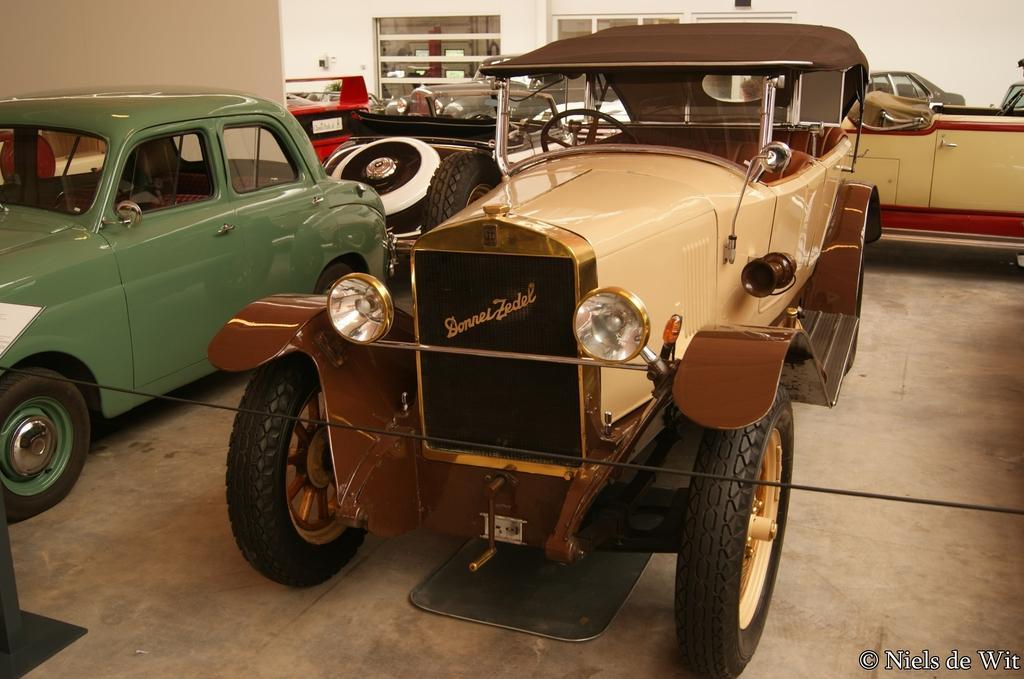Could you give a brief overview of what you see in this image? In the center of the image we can see vehicles, wire. At the top of the image we can see wall, cupboards and some objects. At the bottom of the image there is a floor. 